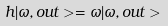<formula> <loc_0><loc_0><loc_500><loc_500>h | \omega , o u t > = \omega | \omega , o u t ></formula> 